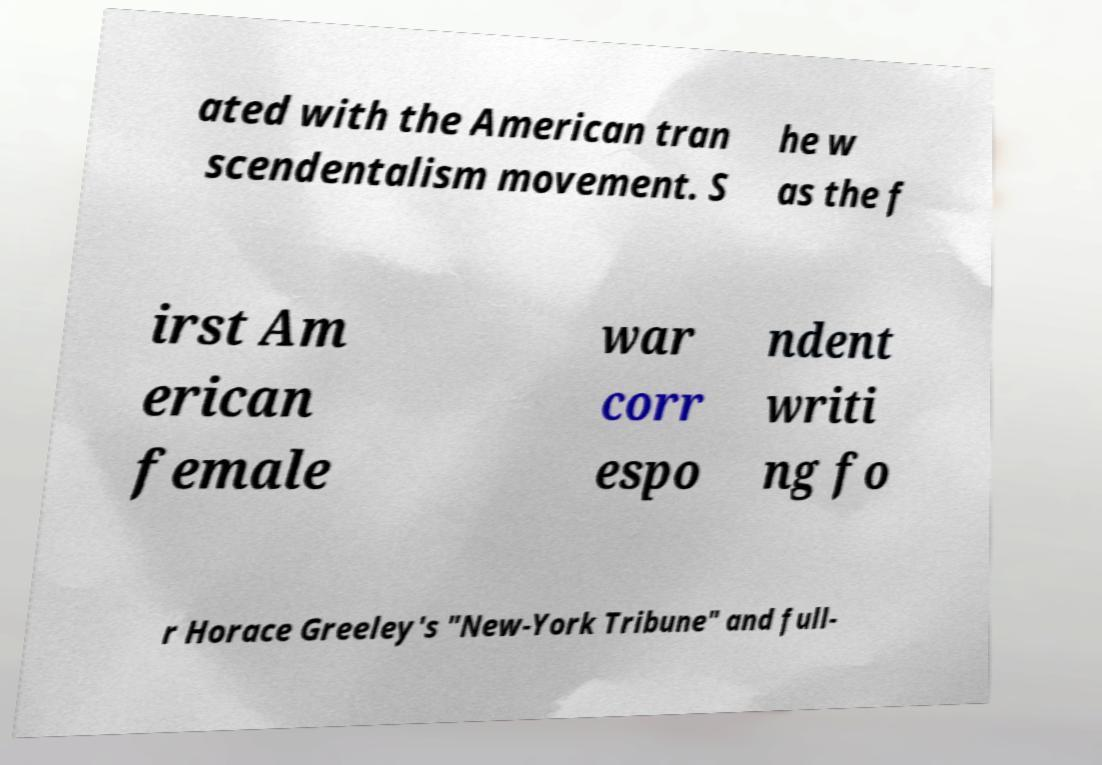I need the written content from this picture converted into text. Can you do that? ated with the American tran scendentalism movement. S he w as the f irst Am erican female war corr espo ndent writi ng fo r Horace Greeley's "New-York Tribune" and full- 